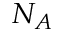Convert formula to latex. <formula><loc_0><loc_0><loc_500><loc_500>N _ { A }</formula> 